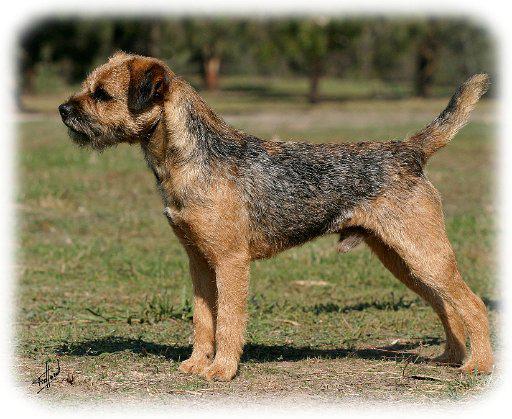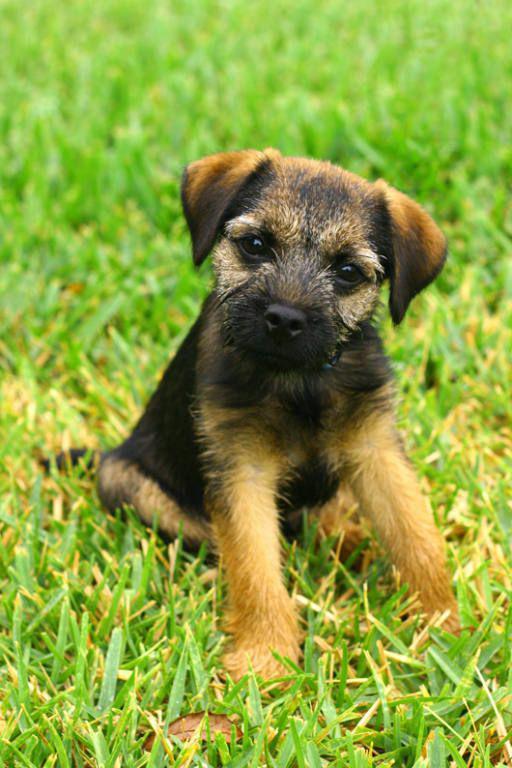The first image is the image on the left, the second image is the image on the right. Evaluate the accuracy of this statement regarding the images: "In one of the images, two border terriers are sitting next to each other.". Is it true? Answer yes or no. No. The first image is the image on the left, the second image is the image on the right. Examine the images to the left and right. Is the description "One image contains twice as many dogs as the other image, and in total, at least two of the dogs depicted face the same direction." accurate? Answer yes or no. No. 